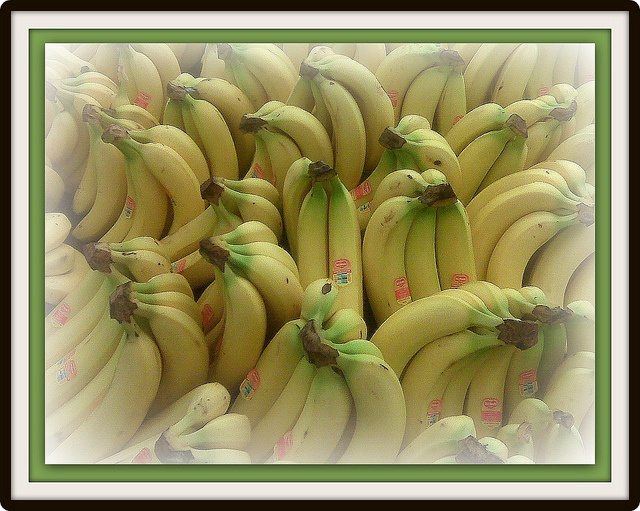Describe the objects in this image and their specific colors. I can see banana in white, tan, beige, and olive tones, banana in white and olive tones, banana in white, olive, and tan tones, banana in white, tan, khaki, and olive tones, and banana in white, olive, beige, and tan tones in this image. 